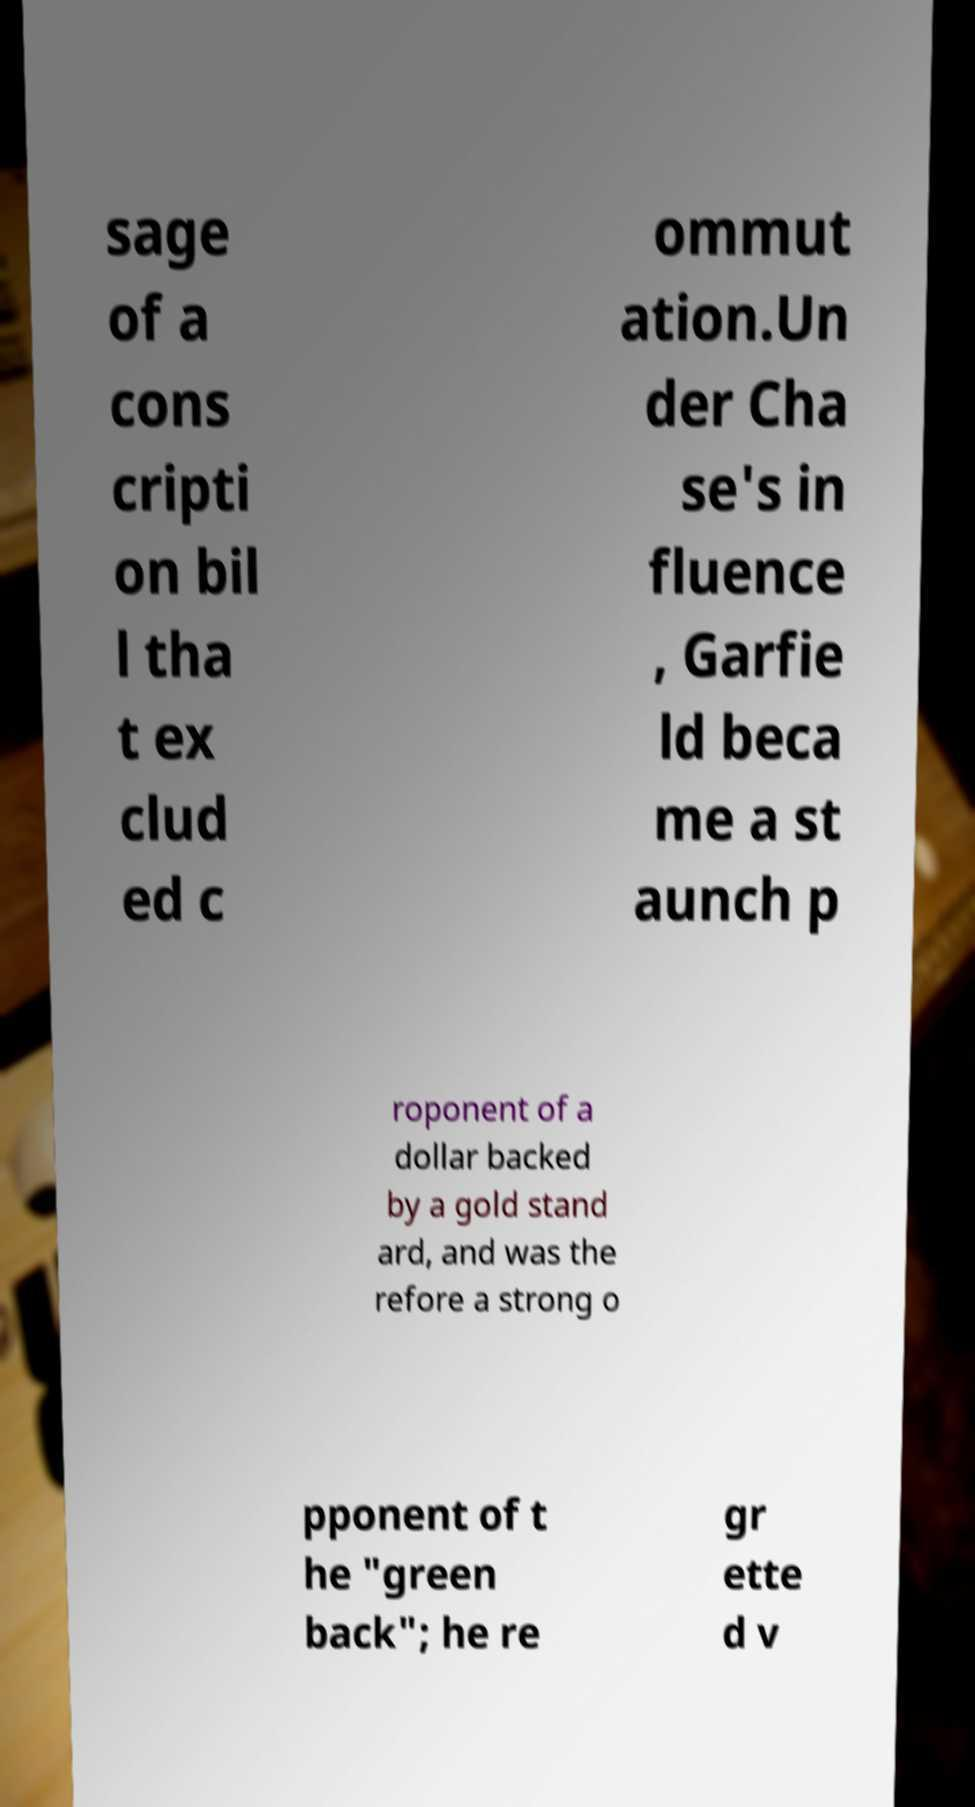Please read and relay the text visible in this image. What does it say? sage of a cons cripti on bil l tha t ex clud ed c ommut ation.Un der Cha se's in fluence , Garfie ld beca me a st aunch p roponent of a dollar backed by a gold stand ard, and was the refore a strong o pponent of t he "green back"; he re gr ette d v 